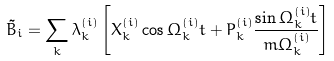<formula> <loc_0><loc_0><loc_500><loc_500>\tilde { B } _ { i } = \sum _ { k } \lambda _ { k } ^ { ( i ) } \left [ X _ { k } ^ { ( i ) } \cos \Omega _ { k } ^ { ( i ) } t + P _ { k } ^ { ( i ) } \frac { \sin \Omega _ { k } ^ { ( i ) } t } { m \Omega _ { k } ^ { ( i ) } } \right ]</formula> 